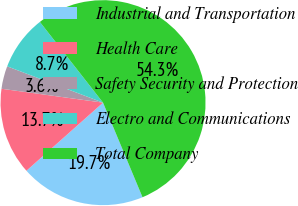Convert chart to OTSL. <chart><loc_0><loc_0><loc_500><loc_500><pie_chart><fcel>Industrial and Transportation<fcel>Health Care<fcel>Safety Security and Protection<fcel>Electro and Communications<fcel>Total Company<nl><fcel>19.73%<fcel>13.73%<fcel>3.6%<fcel>8.67%<fcel>54.28%<nl></chart> 